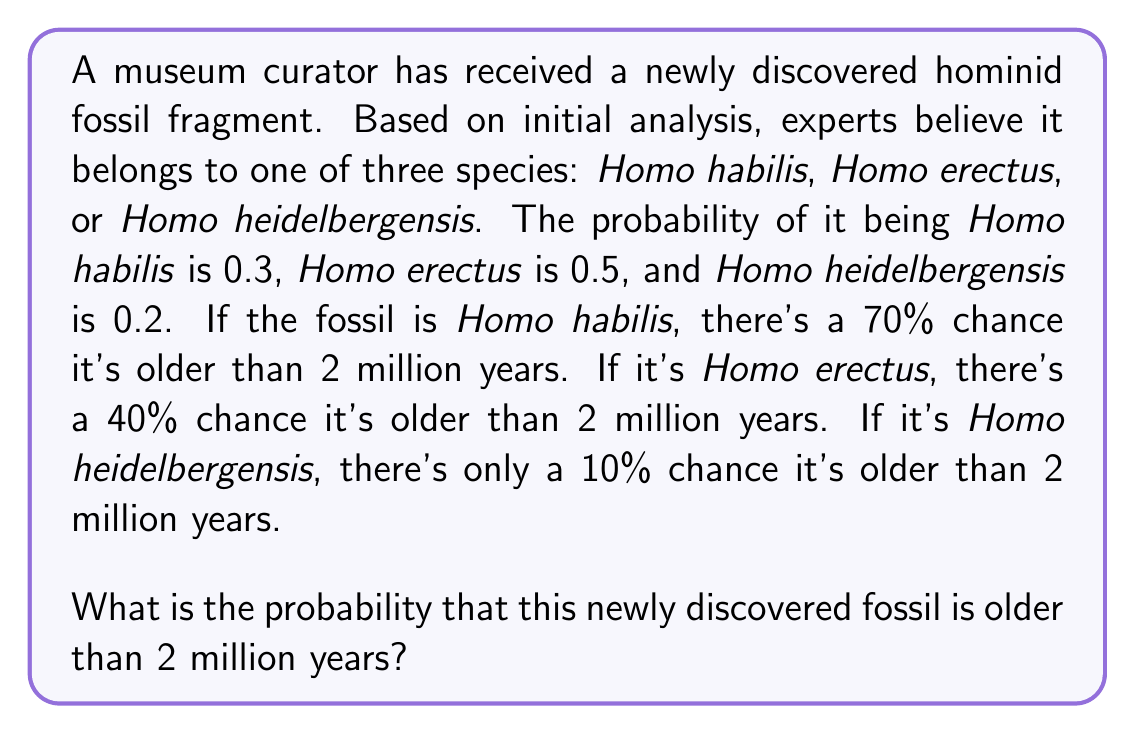Help me with this question. To solve this problem, we'll use the law of total probability. Let's break it down step by step:

1) Let A be the event that the fossil is older than 2 million years.
2) Let H, E, and Hd represent the fossil belonging to Homo habilis, Homo erectus, and Homo heidelbergensis respectively.

3) We're given:
   $P(H) = 0.3$, $P(E) = 0.5$, $P(Hd) = 0.2$
   $P(A|H) = 0.7$, $P(A|E) = 0.4$, $P(A|Hd) = 0.1$

4) The law of total probability states:
   $$P(A) = P(A|H)P(H) + P(A|E)P(E) + P(A|Hd)P(Hd)$$

5) Let's substitute the values:
   $$P(A) = (0.7)(0.3) + (0.4)(0.5) + (0.1)(0.2)$$

6) Now, let's calculate:
   $$P(A) = 0.21 + 0.20 + 0.02$$

7) Adding these up:
   $$P(A) = 0.43$$

Therefore, the probability that the newly discovered fossil is older than 2 million years is 0.43 or 43%.
Answer: 0.43 or 43% 